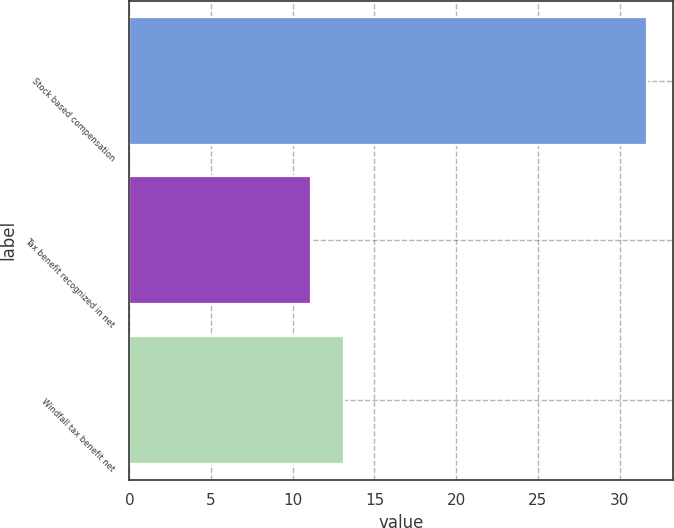Convert chart to OTSL. <chart><loc_0><loc_0><loc_500><loc_500><bar_chart><fcel>Stock based compensation<fcel>Tax benefit recognized in net<fcel>Windfall tax benefit net<nl><fcel>31.7<fcel>11.1<fcel>13.16<nl></chart> 